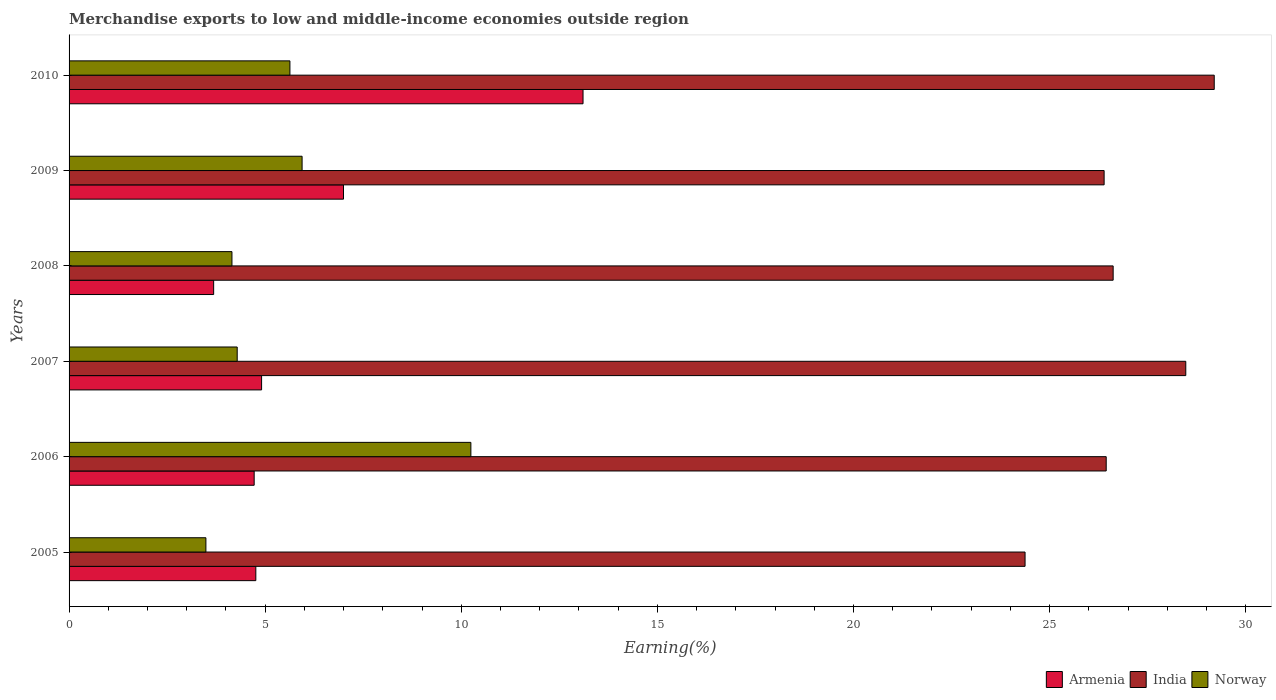How many different coloured bars are there?
Provide a succinct answer. 3. How many groups of bars are there?
Offer a very short reply. 6. Are the number of bars per tick equal to the number of legend labels?
Your response must be concise. Yes. How many bars are there on the 2nd tick from the bottom?
Your answer should be very brief. 3. What is the percentage of amount earned from merchandise exports in Armenia in 2006?
Your answer should be compact. 4.72. Across all years, what is the maximum percentage of amount earned from merchandise exports in India?
Ensure brevity in your answer.  29.2. Across all years, what is the minimum percentage of amount earned from merchandise exports in Norway?
Your answer should be compact. 3.49. In which year was the percentage of amount earned from merchandise exports in Norway maximum?
Your answer should be compact. 2006. In which year was the percentage of amount earned from merchandise exports in Norway minimum?
Offer a very short reply. 2005. What is the total percentage of amount earned from merchandise exports in Armenia in the graph?
Your response must be concise. 38.18. What is the difference between the percentage of amount earned from merchandise exports in Norway in 2007 and that in 2010?
Ensure brevity in your answer.  -1.34. What is the difference between the percentage of amount earned from merchandise exports in Norway in 2008 and the percentage of amount earned from merchandise exports in Armenia in 2007?
Offer a very short reply. -0.76. What is the average percentage of amount earned from merchandise exports in Armenia per year?
Offer a terse response. 6.36. In the year 2005, what is the difference between the percentage of amount earned from merchandise exports in Norway and percentage of amount earned from merchandise exports in India?
Keep it short and to the point. -20.89. In how many years, is the percentage of amount earned from merchandise exports in Armenia greater than 9 %?
Offer a very short reply. 1. What is the ratio of the percentage of amount earned from merchandise exports in Norway in 2005 to that in 2008?
Your answer should be compact. 0.84. What is the difference between the highest and the second highest percentage of amount earned from merchandise exports in India?
Provide a short and direct response. 0.73. What is the difference between the highest and the lowest percentage of amount earned from merchandise exports in Norway?
Your response must be concise. 6.76. In how many years, is the percentage of amount earned from merchandise exports in Armenia greater than the average percentage of amount earned from merchandise exports in Armenia taken over all years?
Your response must be concise. 2. Is the sum of the percentage of amount earned from merchandise exports in Armenia in 2007 and 2008 greater than the maximum percentage of amount earned from merchandise exports in India across all years?
Give a very brief answer. No. What does the 3rd bar from the top in 2009 represents?
Your response must be concise. Armenia. How many bars are there?
Offer a terse response. 18. Are all the bars in the graph horizontal?
Your response must be concise. Yes. What is the difference between two consecutive major ticks on the X-axis?
Provide a short and direct response. 5. Are the values on the major ticks of X-axis written in scientific E-notation?
Your answer should be compact. No. How are the legend labels stacked?
Give a very brief answer. Horizontal. What is the title of the graph?
Provide a succinct answer. Merchandise exports to low and middle-income economies outside region. What is the label or title of the X-axis?
Provide a short and direct response. Earning(%). What is the label or title of the Y-axis?
Your answer should be compact. Years. What is the Earning(%) of Armenia in 2005?
Provide a succinct answer. 4.76. What is the Earning(%) of India in 2005?
Provide a succinct answer. 24.37. What is the Earning(%) in Norway in 2005?
Provide a succinct answer. 3.49. What is the Earning(%) of Armenia in 2006?
Your response must be concise. 4.72. What is the Earning(%) of India in 2006?
Ensure brevity in your answer.  26.44. What is the Earning(%) of Norway in 2006?
Keep it short and to the point. 10.24. What is the Earning(%) in Armenia in 2007?
Provide a succinct answer. 4.91. What is the Earning(%) of India in 2007?
Ensure brevity in your answer.  28.47. What is the Earning(%) of Norway in 2007?
Give a very brief answer. 4.29. What is the Earning(%) in Armenia in 2008?
Offer a terse response. 3.69. What is the Earning(%) of India in 2008?
Provide a short and direct response. 26.62. What is the Earning(%) of Norway in 2008?
Provide a short and direct response. 4.15. What is the Earning(%) of Armenia in 2009?
Your answer should be compact. 7. What is the Earning(%) of India in 2009?
Offer a very short reply. 26.39. What is the Earning(%) in Norway in 2009?
Ensure brevity in your answer.  5.94. What is the Earning(%) of Armenia in 2010?
Your answer should be compact. 13.1. What is the Earning(%) in India in 2010?
Your answer should be compact. 29.2. What is the Earning(%) in Norway in 2010?
Offer a very short reply. 5.63. Across all years, what is the maximum Earning(%) in Armenia?
Give a very brief answer. 13.1. Across all years, what is the maximum Earning(%) in India?
Your answer should be very brief. 29.2. Across all years, what is the maximum Earning(%) in Norway?
Make the answer very short. 10.24. Across all years, what is the minimum Earning(%) of Armenia?
Offer a very short reply. 3.69. Across all years, what is the minimum Earning(%) of India?
Keep it short and to the point. 24.37. Across all years, what is the minimum Earning(%) in Norway?
Your response must be concise. 3.49. What is the total Earning(%) in Armenia in the graph?
Ensure brevity in your answer.  38.18. What is the total Earning(%) in India in the graph?
Offer a very short reply. 161.5. What is the total Earning(%) in Norway in the graph?
Your answer should be very brief. 33.74. What is the difference between the Earning(%) in Armenia in 2005 and that in 2006?
Make the answer very short. 0.04. What is the difference between the Earning(%) in India in 2005 and that in 2006?
Provide a short and direct response. -2.07. What is the difference between the Earning(%) of Norway in 2005 and that in 2006?
Offer a very short reply. -6.76. What is the difference between the Earning(%) in Armenia in 2005 and that in 2007?
Provide a succinct answer. -0.15. What is the difference between the Earning(%) of India in 2005 and that in 2007?
Ensure brevity in your answer.  -4.1. What is the difference between the Earning(%) of Norway in 2005 and that in 2007?
Provide a short and direct response. -0.8. What is the difference between the Earning(%) of Armenia in 2005 and that in 2008?
Give a very brief answer. 1.08. What is the difference between the Earning(%) in India in 2005 and that in 2008?
Provide a short and direct response. -2.25. What is the difference between the Earning(%) in Norway in 2005 and that in 2008?
Your response must be concise. -0.66. What is the difference between the Earning(%) in Armenia in 2005 and that in 2009?
Your answer should be very brief. -2.24. What is the difference between the Earning(%) in India in 2005 and that in 2009?
Your response must be concise. -2.02. What is the difference between the Earning(%) in Norway in 2005 and that in 2009?
Provide a short and direct response. -2.45. What is the difference between the Earning(%) in Armenia in 2005 and that in 2010?
Provide a succinct answer. -8.34. What is the difference between the Earning(%) in India in 2005 and that in 2010?
Give a very brief answer. -4.82. What is the difference between the Earning(%) in Norway in 2005 and that in 2010?
Ensure brevity in your answer.  -2.14. What is the difference between the Earning(%) of Armenia in 2006 and that in 2007?
Offer a terse response. -0.19. What is the difference between the Earning(%) of India in 2006 and that in 2007?
Provide a short and direct response. -2.03. What is the difference between the Earning(%) of Norway in 2006 and that in 2007?
Your response must be concise. 5.96. What is the difference between the Earning(%) in Armenia in 2006 and that in 2008?
Offer a very short reply. 1.03. What is the difference between the Earning(%) of India in 2006 and that in 2008?
Provide a short and direct response. -0.18. What is the difference between the Earning(%) of Norway in 2006 and that in 2008?
Keep it short and to the point. 6.09. What is the difference between the Earning(%) of Armenia in 2006 and that in 2009?
Offer a terse response. -2.28. What is the difference between the Earning(%) of India in 2006 and that in 2009?
Offer a very short reply. 0.05. What is the difference between the Earning(%) in Norway in 2006 and that in 2009?
Offer a very short reply. 4.3. What is the difference between the Earning(%) of Armenia in 2006 and that in 2010?
Your response must be concise. -8.38. What is the difference between the Earning(%) of India in 2006 and that in 2010?
Your answer should be very brief. -2.75. What is the difference between the Earning(%) of Norway in 2006 and that in 2010?
Provide a short and direct response. 4.61. What is the difference between the Earning(%) of Armenia in 2007 and that in 2008?
Keep it short and to the point. 1.22. What is the difference between the Earning(%) of India in 2007 and that in 2008?
Your answer should be very brief. 1.85. What is the difference between the Earning(%) of Norway in 2007 and that in 2008?
Ensure brevity in your answer.  0.13. What is the difference between the Earning(%) in Armenia in 2007 and that in 2009?
Your answer should be very brief. -2.09. What is the difference between the Earning(%) in India in 2007 and that in 2009?
Make the answer very short. 2.08. What is the difference between the Earning(%) of Norway in 2007 and that in 2009?
Your answer should be very brief. -1.65. What is the difference between the Earning(%) of Armenia in 2007 and that in 2010?
Offer a terse response. -8.2. What is the difference between the Earning(%) in India in 2007 and that in 2010?
Offer a terse response. -0.73. What is the difference between the Earning(%) of Norway in 2007 and that in 2010?
Offer a very short reply. -1.34. What is the difference between the Earning(%) in Armenia in 2008 and that in 2009?
Ensure brevity in your answer.  -3.31. What is the difference between the Earning(%) of India in 2008 and that in 2009?
Make the answer very short. 0.23. What is the difference between the Earning(%) of Norway in 2008 and that in 2009?
Keep it short and to the point. -1.79. What is the difference between the Earning(%) of Armenia in 2008 and that in 2010?
Provide a succinct answer. -9.42. What is the difference between the Earning(%) in India in 2008 and that in 2010?
Keep it short and to the point. -2.58. What is the difference between the Earning(%) in Norway in 2008 and that in 2010?
Your response must be concise. -1.48. What is the difference between the Earning(%) in Armenia in 2009 and that in 2010?
Ensure brevity in your answer.  -6.11. What is the difference between the Earning(%) in India in 2009 and that in 2010?
Ensure brevity in your answer.  -2.81. What is the difference between the Earning(%) in Norway in 2009 and that in 2010?
Offer a very short reply. 0.31. What is the difference between the Earning(%) in Armenia in 2005 and the Earning(%) in India in 2006?
Provide a short and direct response. -21.68. What is the difference between the Earning(%) of Armenia in 2005 and the Earning(%) of Norway in 2006?
Provide a short and direct response. -5.48. What is the difference between the Earning(%) of India in 2005 and the Earning(%) of Norway in 2006?
Your answer should be very brief. 14.13. What is the difference between the Earning(%) of Armenia in 2005 and the Earning(%) of India in 2007?
Ensure brevity in your answer.  -23.71. What is the difference between the Earning(%) in Armenia in 2005 and the Earning(%) in Norway in 2007?
Your answer should be compact. 0.47. What is the difference between the Earning(%) in India in 2005 and the Earning(%) in Norway in 2007?
Ensure brevity in your answer.  20.09. What is the difference between the Earning(%) in Armenia in 2005 and the Earning(%) in India in 2008?
Give a very brief answer. -21.86. What is the difference between the Earning(%) of Armenia in 2005 and the Earning(%) of Norway in 2008?
Your answer should be compact. 0.61. What is the difference between the Earning(%) of India in 2005 and the Earning(%) of Norway in 2008?
Give a very brief answer. 20.22. What is the difference between the Earning(%) of Armenia in 2005 and the Earning(%) of India in 2009?
Provide a succinct answer. -21.63. What is the difference between the Earning(%) in Armenia in 2005 and the Earning(%) in Norway in 2009?
Offer a terse response. -1.18. What is the difference between the Earning(%) in India in 2005 and the Earning(%) in Norway in 2009?
Keep it short and to the point. 18.43. What is the difference between the Earning(%) of Armenia in 2005 and the Earning(%) of India in 2010?
Give a very brief answer. -24.44. What is the difference between the Earning(%) in Armenia in 2005 and the Earning(%) in Norway in 2010?
Offer a terse response. -0.87. What is the difference between the Earning(%) of India in 2005 and the Earning(%) of Norway in 2010?
Your response must be concise. 18.74. What is the difference between the Earning(%) in Armenia in 2006 and the Earning(%) in India in 2007?
Offer a very short reply. -23.75. What is the difference between the Earning(%) of Armenia in 2006 and the Earning(%) of Norway in 2007?
Make the answer very short. 0.43. What is the difference between the Earning(%) of India in 2006 and the Earning(%) of Norway in 2007?
Keep it short and to the point. 22.16. What is the difference between the Earning(%) in Armenia in 2006 and the Earning(%) in India in 2008?
Make the answer very short. -21.9. What is the difference between the Earning(%) of Armenia in 2006 and the Earning(%) of Norway in 2008?
Offer a very short reply. 0.57. What is the difference between the Earning(%) in India in 2006 and the Earning(%) in Norway in 2008?
Offer a very short reply. 22.29. What is the difference between the Earning(%) of Armenia in 2006 and the Earning(%) of India in 2009?
Offer a very short reply. -21.67. What is the difference between the Earning(%) in Armenia in 2006 and the Earning(%) in Norway in 2009?
Make the answer very short. -1.22. What is the difference between the Earning(%) in India in 2006 and the Earning(%) in Norway in 2009?
Offer a very short reply. 20.5. What is the difference between the Earning(%) of Armenia in 2006 and the Earning(%) of India in 2010?
Your answer should be very brief. -24.48. What is the difference between the Earning(%) in Armenia in 2006 and the Earning(%) in Norway in 2010?
Ensure brevity in your answer.  -0.91. What is the difference between the Earning(%) of India in 2006 and the Earning(%) of Norway in 2010?
Ensure brevity in your answer.  20.81. What is the difference between the Earning(%) in Armenia in 2007 and the Earning(%) in India in 2008?
Provide a short and direct response. -21.71. What is the difference between the Earning(%) of Armenia in 2007 and the Earning(%) of Norway in 2008?
Offer a terse response. 0.76. What is the difference between the Earning(%) in India in 2007 and the Earning(%) in Norway in 2008?
Your answer should be very brief. 24.32. What is the difference between the Earning(%) in Armenia in 2007 and the Earning(%) in India in 2009?
Your answer should be compact. -21.48. What is the difference between the Earning(%) in Armenia in 2007 and the Earning(%) in Norway in 2009?
Give a very brief answer. -1.03. What is the difference between the Earning(%) of India in 2007 and the Earning(%) of Norway in 2009?
Keep it short and to the point. 22.53. What is the difference between the Earning(%) in Armenia in 2007 and the Earning(%) in India in 2010?
Give a very brief answer. -24.29. What is the difference between the Earning(%) of Armenia in 2007 and the Earning(%) of Norway in 2010?
Give a very brief answer. -0.72. What is the difference between the Earning(%) in India in 2007 and the Earning(%) in Norway in 2010?
Offer a terse response. 22.84. What is the difference between the Earning(%) of Armenia in 2008 and the Earning(%) of India in 2009?
Make the answer very short. -22.7. What is the difference between the Earning(%) of Armenia in 2008 and the Earning(%) of Norway in 2009?
Keep it short and to the point. -2.25. What is the difference between the Earning(%) of India in 2008 and the Earning(%) of Norway in 2009?
Offer a terse response. 20.68. What is the difference between the Earning(%) of Armenia in 2008 and the Earning(%) of India in 2010?
Your response must be concise. -25.51. What is the difference between the Earning(%) in Armenia in 2008 and the Earning(%) in Norway in 2010?
Your response must be concise. -1.94. What is the difference between the Earning(%) in India in 2008 and the Earning(%) in Norway in 2010?
Make the answer very short. 20.99. What is the difference between the Earning(%) of Armenia in 2009 and the Earning(%) of India in 2010?
Keep it short and to the point. -22.2. What is the difference between the Earning(%) in Armenia in 2009 and the Earning(%) in Norway in 2010?
Your answer should be very brief. 1.37. What is the difference between the Earning(%) of India in 2009 and the Earning(%) of Norway in 2010?
Your answer should be very brief. 20.76. What is the average Earning(%) in Armenia per year?
Provide a succinct answer. 6.36. What is the average Earning(%) in India per year?
Your response must be concise. 26.92. What is the average Earning(%) of Norway per year?
Make the answer very short. 5.62. In the year 2005, what is the difference between the Earning(%) in Armenia and Earning(%) in India?
Your answer should be very brief. -19.61. In the year 2005, what is the difference between the Earning(%) in Armenia and Earning(%) in Norway?
Make the answer very short. 1.27. In the year 2005, what is the difference between the Earning(%) of India and Earning(%) of Norway?
Your answer should be compact. 20.89. In the year 2006, what is the difference between the Earning(%) in Armenia and Earning(%) in India?
Give a very brief answer. -21.72. In the year 2006, what is the difference between the Earning(%) of Armenia and Earning(%) of Norway?
Give a very brief answer. -5.52. In the year 2006, what is the difference between the Earning(%) of India and Earning(%) of Norway?
Your response must be concise. 16.2. In the year 2007, what is the difference between the Earning(%) in Armenia and Earning(%) in India?
Your response must be concise. -23.56. In the year 2007, what is the difference between the Earning(%) of Armenia and Earning(%) of Norway?
Provide a succinct answer. 0.62. In the year 2007, what is the difference between the Earning(%) of India and Earning(%) of Norway?
Provide a succinct answer. 24.18. In the year 2008, what is the difference between the Earning(%) in Armenia and Earning(%) in India?
Offer a very short reply. -22.93. In the year 2008, what is the difference between the Earning(%) in Armenia and Earning(%) in Norway?
Keep it short and to the point. -0.47. In the year 2008, what is the difference between the Earning(%) of India and Earning(%) of Norway?
Give a very brief answer. 22.47. In the year 2009, what is the difference between the Earning(%) of Armenia and Earning(%) of India?
Offer a terse response. -19.39. In the year 2009, what is the difference between the Earning(%) of Armenia and Earning(%) of Norway?
Ensure brevity in your answer.  1.06. In the year 2009, what is the difference between the Earning(%) of India and Earning(%) of Norway?
Offer a terse response. 20.45. In the year 2010, what is the difference between the Earning(%) of Armenia and Earning(%) of India?
Offer a very short reply. -16.09. In the year 2010, what is the difference between the Earning(%) in Armenia and Earning(%) in Norway?
Provide a succinct answer. 7.47. In the year 2010, what is the difference between the Earning(%) in India and Earning(%) in Norway?
Provide a short and direct response. 23.57. What is the ratio of the Earning(%) of Armenia in 2005 to that in 2006?
Ensure brevity in your answer.  1.01. What is the ratio of the Earning(%) in India in 2005 to that in 2006?
Make the answer very short. 0.92. What is the ratio of the Earning(%) in Norway in 2005 to that in 2006?
Your answer should be compact. 0.34. What is the ratio of the Earning(%) in Armenia in 2005 to that in 2007?
Offer a terse response. 0.97. What is the ratio of the Earning(%) of India in 2005 to that in 2007?
Ensure brevity in your answer.  0.86. What is the ratio of the Earning(%) in Norway in 2005 to that in 2007?
Offer a very short reply. 0.81. What is the ratio of the Earning(%) in Armenia in 2005 to that in 2008?
Your response must be concise. 1.29. What is the ratio of the Earning(%) of India in 2005 to that in 2008?
Your response must be concise. 0.92. What is the ratio of the Earning(%) in Norway in 2005 to that in 2008?
Offer a terse response. 0.84. What is the ratio of the Earning(%) in Armenia in 2005 to that in 2009?
Make the answer very short. 0.68. What is the ratio of the Earning(%) of India in 2005 to that in 2009?
Make the answer very short. 0.92. What is the ratio of the Earning(%) in Norway in 2005 to that in 2009?
Provide a short and direct response. 0.59. What is the ratio of the Earning(%) of Armenia in 2005 to that in 2010?
Your response must be concise. 0.36. What is the ratio of the Earning(%) of India in 2005 to that in 2010?
Your response must be concise. 0.83. What is the ratio of the Earning(%) in Norway in 2005 to that in 2010?
Make the answer very short. 0.62. What is the ratio of the Earning(%) in Armenia in 2006 to that in 2007?
Your answer should be very brief. 0.96. What is the ratio of the Earning(%) of India in 2006 to that in 2007?
Your response must be concise. 0.93. What is the ratio of the Earning(%) of Norway in 2006 to that in 2007?
Offer a terse response. 2.39. What is the ratio of the Earning(%) of Armenia in 2006 to that in 2008?
Give a very brief answer. 1.28. What is the ratio of the Earning(%) in Norway in 2006 to that in 2008?
Provide a succinct answer. 2.47. What is the ratio of the Earning(%) in Armenia in 2006 to that in 2009?
Give a very brief answer. 0.67. What is the ratio of the Earning(%) in India in 2006 to that in 2009?
Provide a succinct answer. 1. What is the ratio of the Earning(%) in Norway in 2006 to that in 2009?
Make the answer very short. 1.72. What is the ratio of the Earning(%) of Armenia in 2006 to that in 2010?
Your response must be concise. 0.36. What is the ratio of the Earning(%) of India in 2006 to that in 2010?
Your answer should be very brief. 0.91. What is the ratio of the Earning(%) in Norway in 2006 to that in 2010?
Provide a succinct answer. 1.82. What is the ratio of the Earning(%) in Armenia in 2007 to that in 2008?
Ensure brevity in your answer.  1.33. What is the ratio of the Earning(%) of India in 2007 to that in 2008?
Ensure brevity in your answer.  1.07. What is the ratio of the Earning(%) in Norway in 2007 to that in 2008?
Provide a short and direct response. 1.03. What is the ratio of the Earning(%) of Armenia in 2007 to that in 2009?
Your answer should be very brief. 0.7. What is the ratio of the Earning(%) in India in 2007 to that in 2009?
Offer a very short reply. 1.08. What is the ratio of the Earning(%) of Norway in 2007 to that in 2009?
Make the answer very short. 0.72. What is the ratio of the Earning(%) in Armenia in 2007 to that in 2010?
Provide a short and direct response. 0.37. What is the ratio of the Earning(%) in India in 2007 to that in 2010?
Keep it short and to the point. 0.98. What is the ratio of the Earning(%) of Norway in 2007 to that in 2010?
Your answer should be compact. 0.76. What is the ratio of the Earning(%) in Armenia in 2008 to that in 2009?
Make the answer very short. 0.53. What is the ratio of the Earning(%) of India in 2008 to that in 2009?
Your answer should be very brief. 1.01. What is the ratio of the Earning(%) of Norway in 2008 to that in 2009?
Provide a succinct answer. 0.7. What is the ratio of the Earning(%) of Armenia in 2008 to that in 2010?
Your answer should be compact. 0.28. What is the ratio of the Earning(%) of India in 2008 to that in 2010?
Offer a terse response. 0.91. What is the ratio of the Earning(%) in Norway in 2008 to that in 2010?
Give a very brief answer. 0.74. What is the ratio of the Earning(%) in Armenia in 2009 to that in 2010?
Ensure brevity in your answer.  0.53. What is the ratio of the Earning(%) in India in 2009 to that in 2010?
Offer a very short reply. 0.9. What is the ratio of the Earning(%) of Norway in 2009 to that in 2010?
Give a very brief answer. 1.06. What is the difference between the highest and the second highest Earning(%) of Armenia?
Make the answer very short. 6.11. What is the difference between the highest and the second highest Earning(%) in India?
Your answer should be very brief. 0.73. What is the difference between the highest and the second highest Earning(%) of Norway?
Offer a terse response. 4.3. What is the difference between the highest and the lowest Earning(%) in Armenia?
Your response must be concise. 9.42. What is the difference between the highest and the lowest Earning(%) of India?
Offer a terse response. 4.82. What is the difference between the highest and the lowest Earning(%) of Norway?
Give a very brief answer. 6.76. 